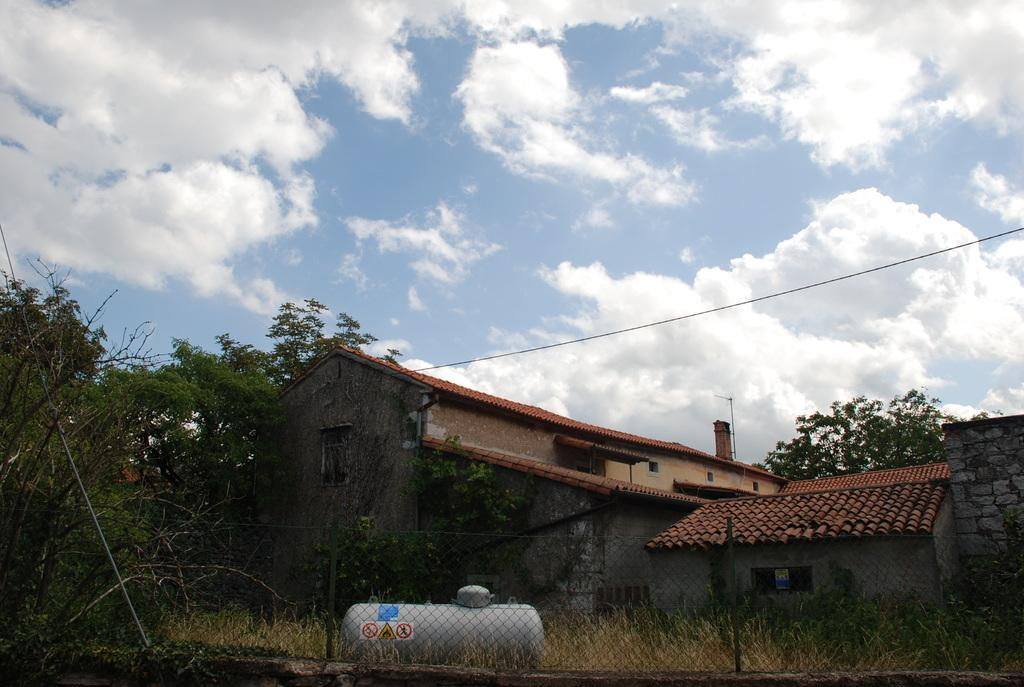What type of structures are present in the image? There are sheds in the image. What other natural elements can be seen in the image? There are trees in the image. What is located at the bottom of the image? There is a fence at the bottom of the image. What type of vehicle is present in the image? There is a tanker in the image. What is visible in the background of the image? The sky and a wire are visible in the background of the image. What type of instrument is being played by the tree in the image? There is no instrument being played by the tree in the image, as trees are not capable of playing instruments. What color is the nose of the tanker in the image? Tankers do not have noses, as they are vehicles and not living beings. 